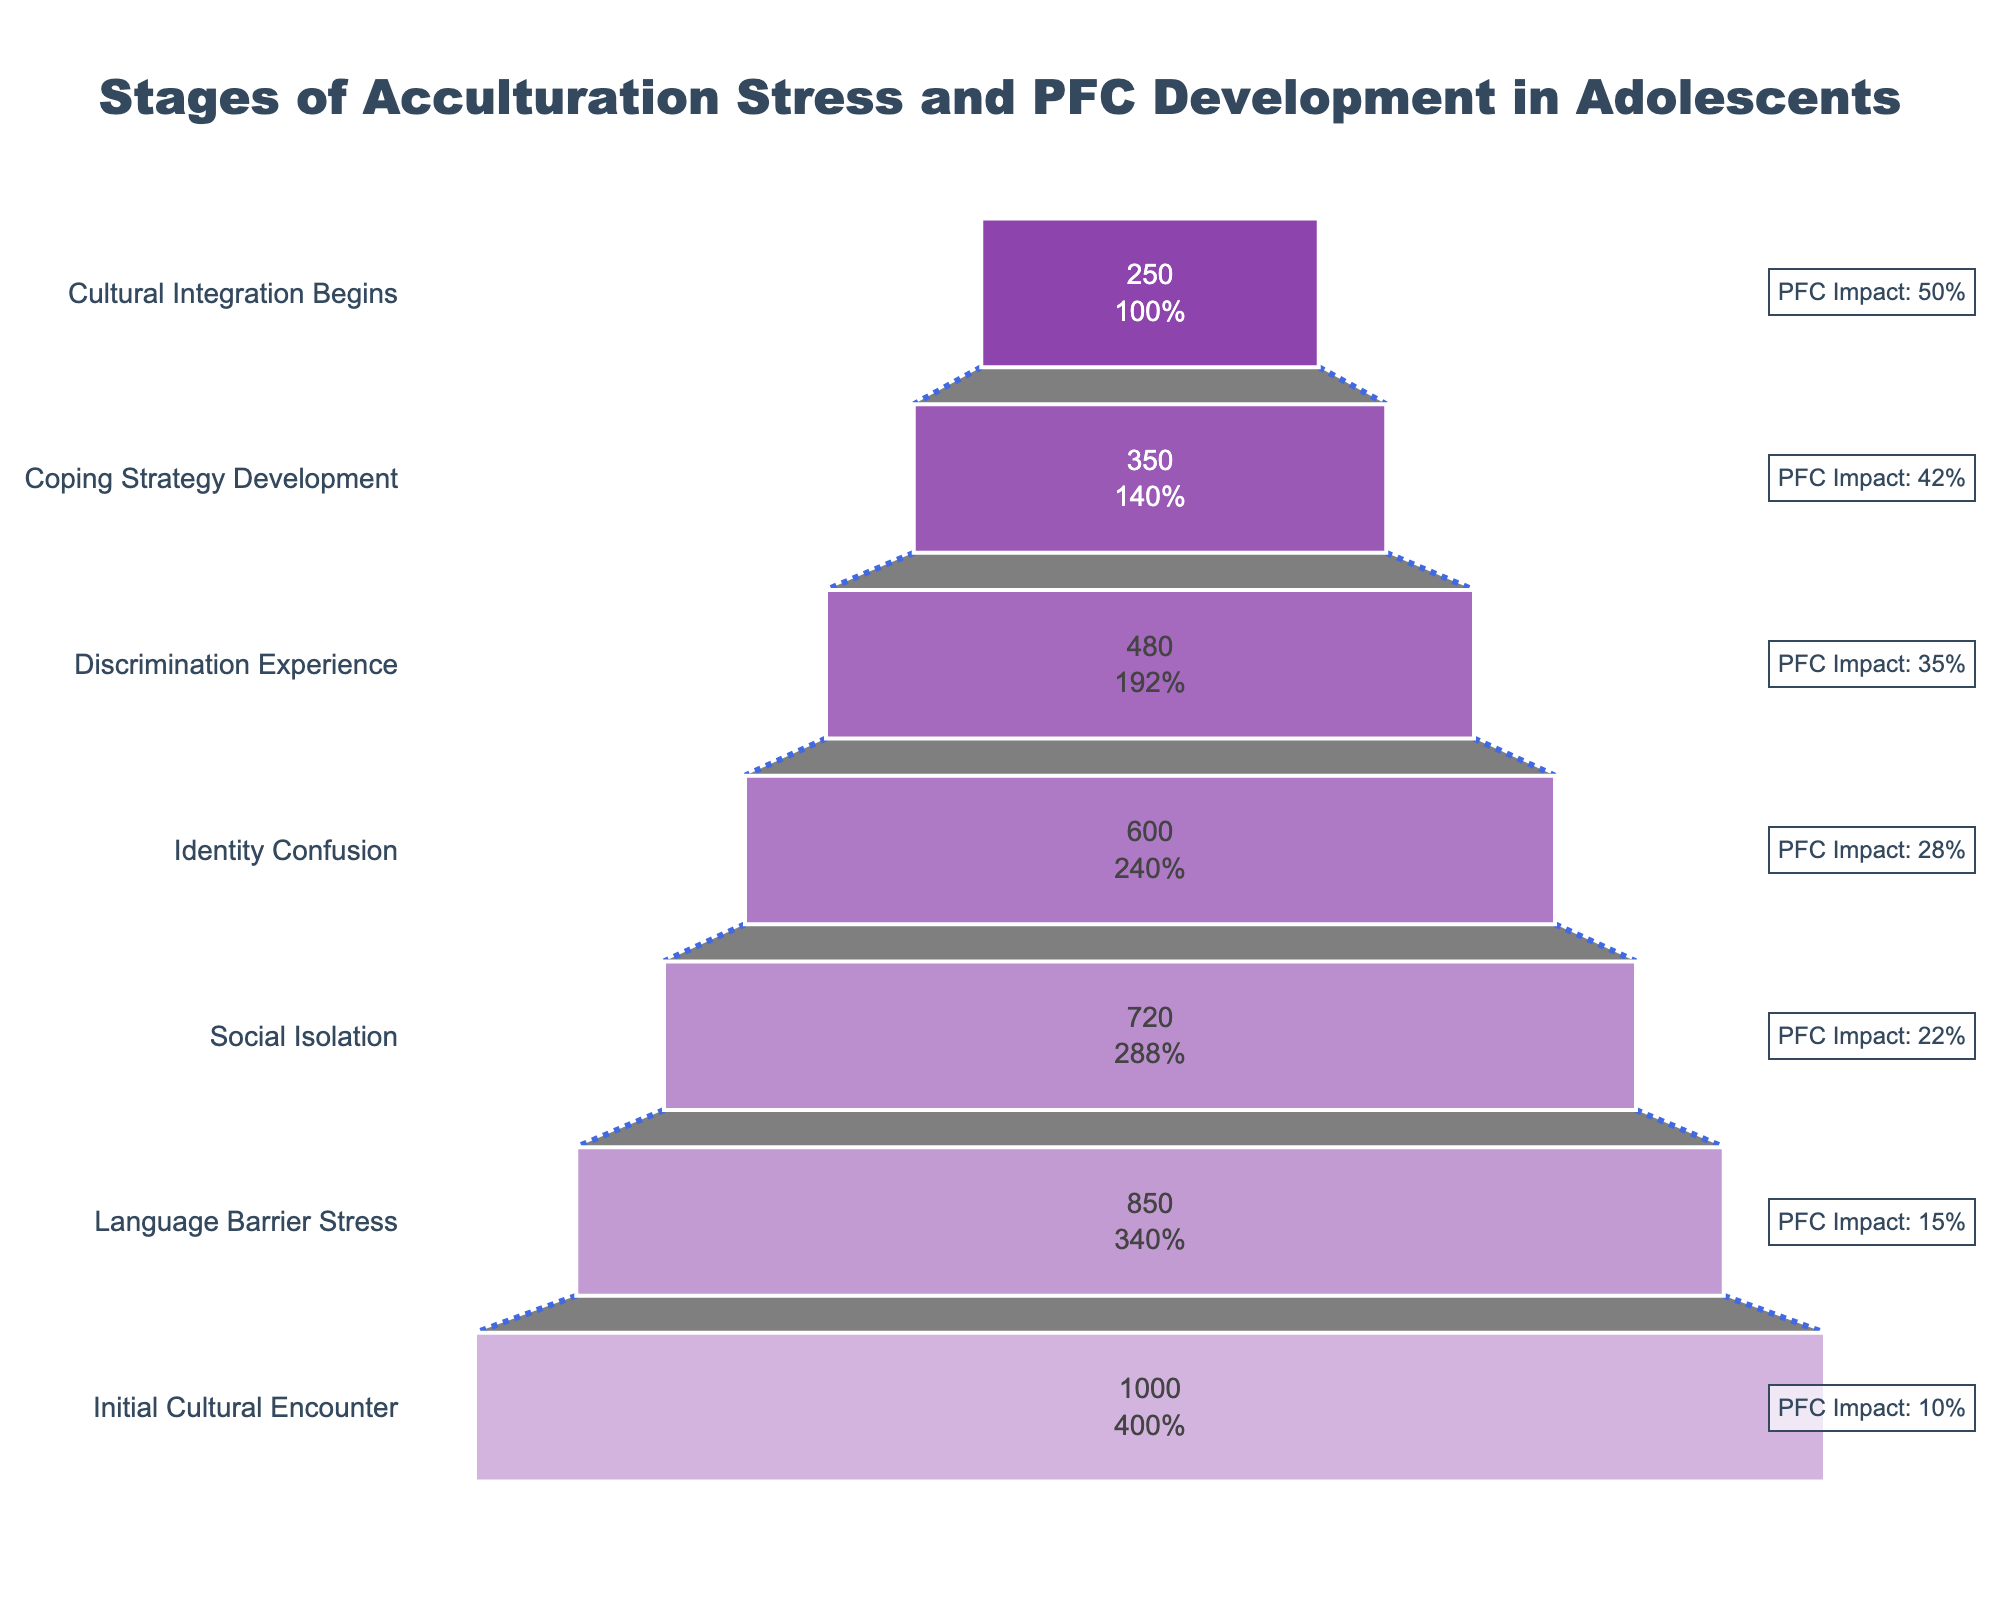what is the title of the chart? The title of the chart is displayed at the top of the figure. It helps to understand the content and focus of the chart. In this case, the title clearly states the subject of the chart.
Answer: Stages of Acculturation Stress and PFC Development in Adolescents How many stages are represented in the chart? To find the number of stages, we can count the number of categories listed on the y-axis. Each category represents a different stage in the process.
Answer: 7 At which stage do participants experience the highest impact on PFC development? To identify the stage with the highest impact on prefrontal cortex (PFC) development, look for the stage with the highest percentage value in the annotations next to the bars.
Answer: Cultural Integration Begins How does the number of participants change from Language Barrier Stress to Social Isolation? Compare the number of participants in the 'Language Barrier Stress' stage with that in the 'Social Isolation' stage by calculating the difference.
Answer: Decreases by 130 What is the overall trend in the number of participants as they progress through the stages? Observing the bars from top to bottom, note whether the number of participants increases, decreases, or remains constant through each successive stage.
Answer: Decreases Which stage has the smallest number of participants? Find the stage with the smallest bar on the x-axis, as the length of the bar represents the number of participants.
Answer: Cultural Integration Begins What percentage of participants remain at the Discrimination Experience stage compared to the initial cultural encounter? Calculate the percentage of participants at the 'Discrimination Experience' stage relative to the 'Initial Cultural Encounter' stage by dividing the number of participants at the 'Discrimination Experience' stage by the number of participants at the 'Initial Cultural Encounter' stage and multiplying by 100.
Answer: 48% Compare the impact on PFC development between Identity Confusion and Language Barrier Stress stages. Look at the annotated PFC impact percentages next to the bars for both 'Identity Confusion' and 'Language Barrier Stress' stages, then compare these values.
Answer: Identity Confusion has 13% higher impact What is the difference in PFC development impact between Social Isolation and Coping Strategy Development stages? To find this, subtract the PFC development impact percentage of 'Social Isolation' from that of 'Coping Strategy Development'.
Answer: 20% How much does PFC development impact increase from the initial cultural encounter to cultural integration begins? Subtract the PFC development impact percentage at the 'Initial Cultural Encounter' stage from the percentage at the 'Cultural Integration Begins' stage.
Answer: 40% 